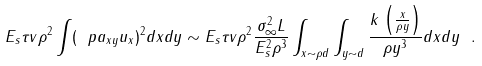Convert formula to latex. <formula><loc_0><loc_0><loc_500><loc_500>E _ { s } \tau v \rho ^ { 2 } \int ( \ p a _ { x y } u _ { x } ) ^ { 2 } d x d y \sim E _ { s } \tau v \rho ^ { 2 } \frac { \sigma ^ { 2 } _ { \infty } L } { E ^ { 2 } _ { s } \rho ^ { 3 } } \int _ { x \sim \rho d } \int _ { y \sim d } \frac { k \, \left ( \frac { x } { \rho y } \right ) } { \rho y ^ { 3 } } d x d y \ .</formula> 